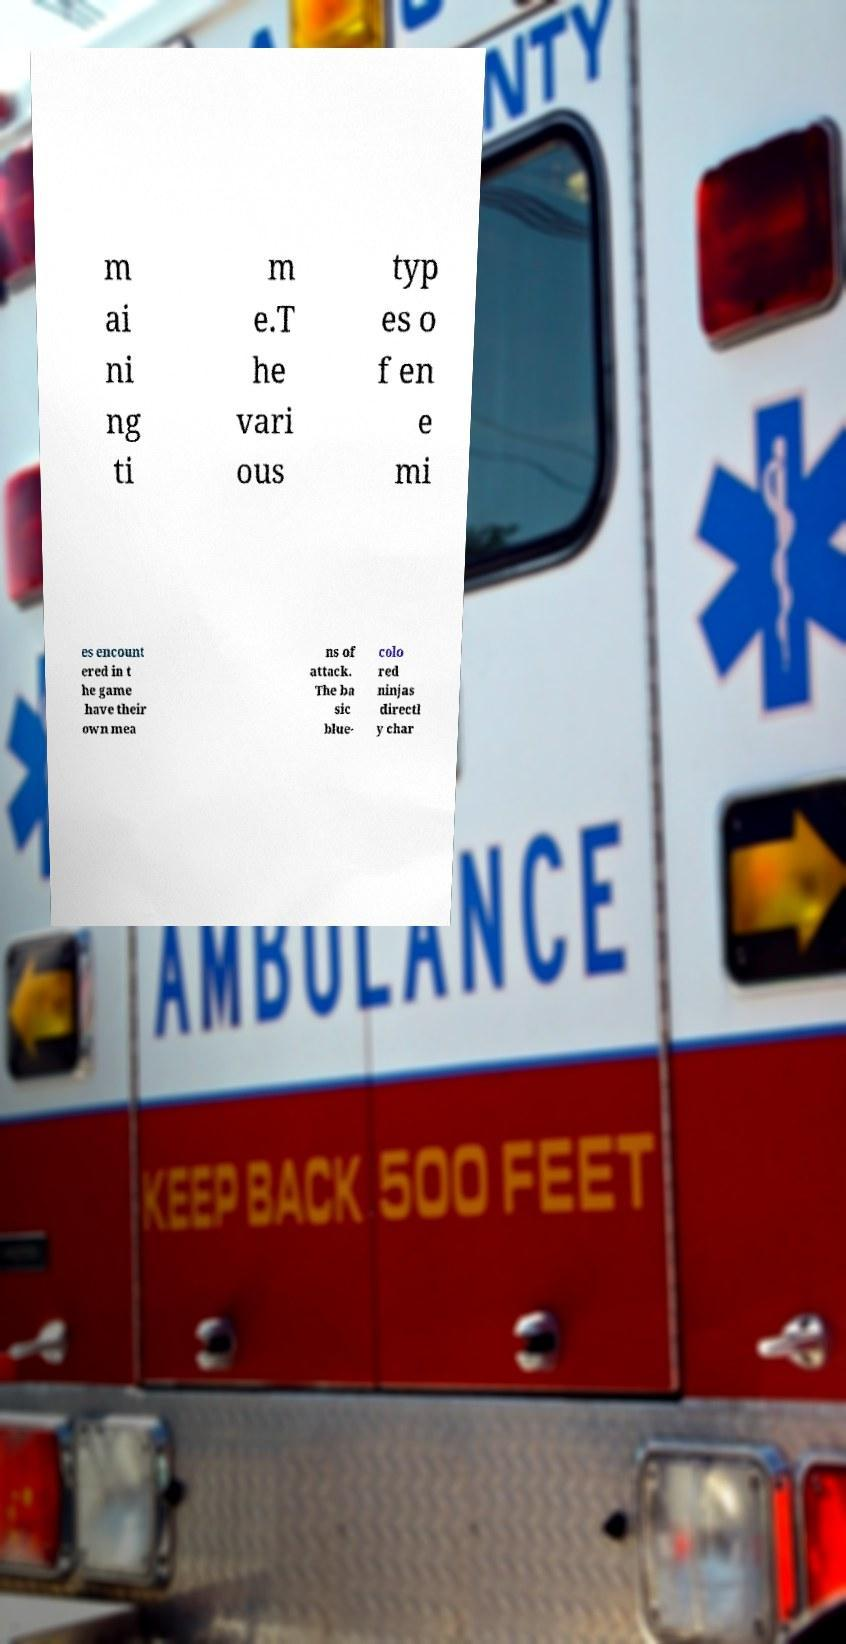I need the written content from this picture converted into text. Can you do that? m ai ni ng ti m e.T he vari ous typ es o f en e mi es encount ered in t he game have their own mea ns of attack. The ba sic blue- colo red ninjas directl y char 